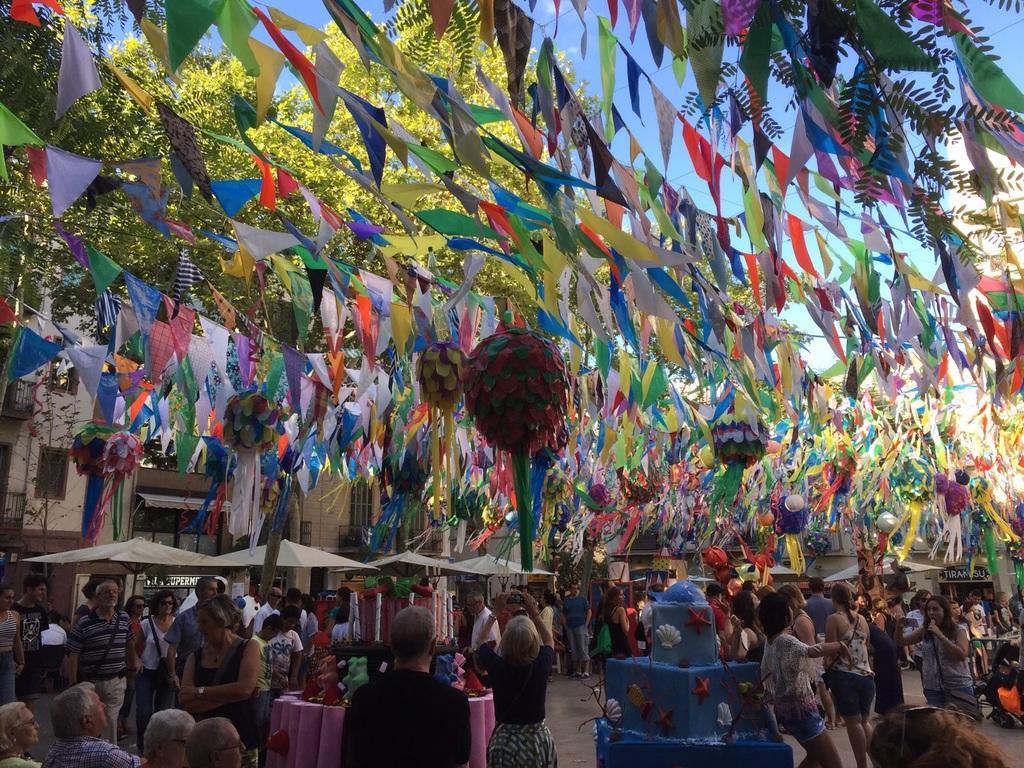Please provide a concise description of this image. This picture looks like a carnival, at the top there are some decorative items and flags, at the bottom there is a tent , under the tent there is crowd and on the road few people visible and some objects kept on the road, at the top there is a tree, building, the sky visible. 